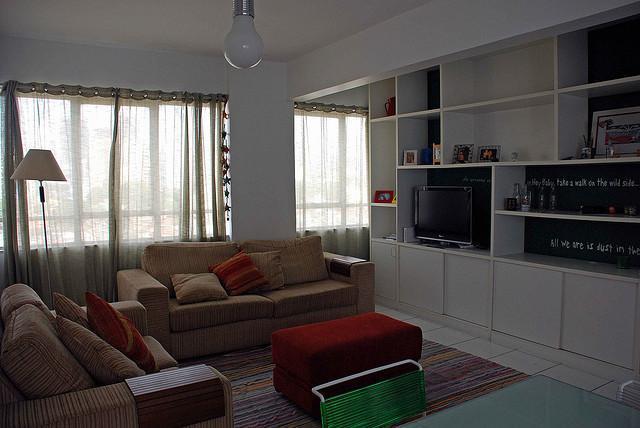How many pillows are on the couches?
Give a very brief answer. 6. How many chairs are identical?
Give a very brief answer. 2. How many chairs can be seen?
Give a very brief answer. 2. How many couches can you see?
Give a very brief answer. 2. How many people are eating food?
Give a very brief answer. 0. 